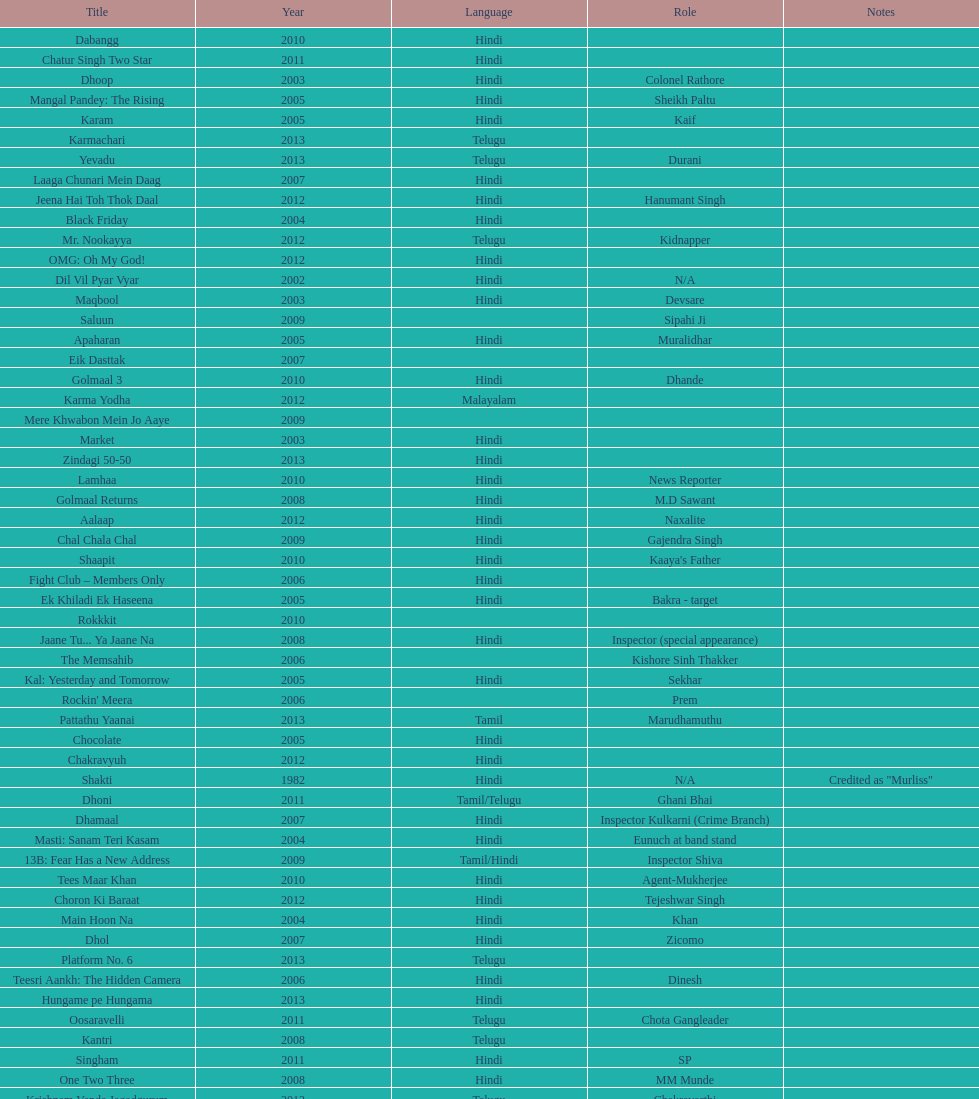How many roles has this actor had? 36. 